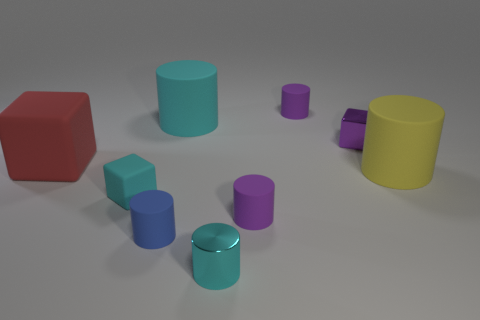What is the size of the cyan thing that is the same shape as the large red rubber thing?
Your response must be concise. Small. There is a matte thing that is the same color as the small rubber cube; what is its size?
Keep it short and to the point. Large. The tiny purple rubber object behind the tiny shiny block has what shape?
Provide a succinct answer. Cylinder. Is the color of the big matte object left of the small matte cube the same as the tiny shiny cylinder?
Provide a short and direct response. No. There is a large cylinder that is the same color as the small rubber block; what is its material?
Provide a succinct answer. Rubber. There is a cyan cylinder that is behind the shiny cylinder; is it the same size as the small cyan rubber block?
Your response must be concise. No. Are there any shiny things of the same color as the small shiny cylinder?
Offer a terse response. No. Is there a big red object behind the large matte object on the right side of the small metal cylinder?
Your answer should be very brief. Yes. Are there any yellow cylinders made of the same material as the tiny cyan block?
Your response must be concise. Yes. What is the material of the large thing that is to the left of the cyan thing on the left side of the cyan rubber cylinder?
Keep it short and to the point. Rubber. 